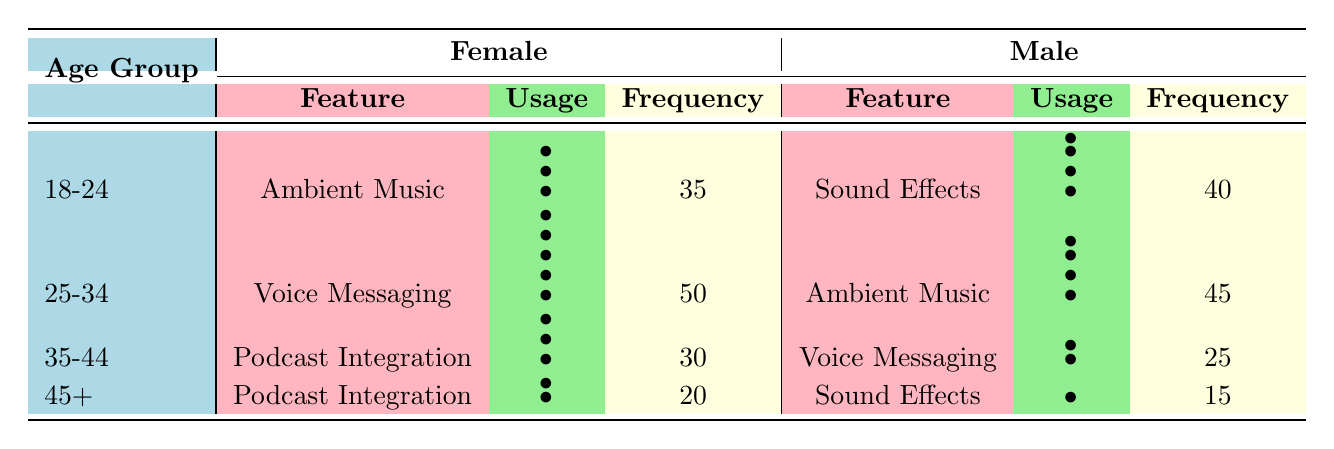What is the most frequently used sound feature by females aged 25-34? From the table, we can see that the frequency for "Voice Messaging" among females aged 25-34 is 50, which is the highest value listed in that row.
Answer: Voice Messaging How many sound features are listed for males in the age group 18-24? In the age group 18-24, the table lists one sound feature for males, which is "Sound Effects".
Answer: 1 What is the frequency of usage for Podcast Integration among females aged 35-44? The table shows that the frequency of usage for "Podcast Integration" among females aged 35-44 is 30.
Answer: 30 Which gender has a higher frequency of sound feature usage for Ambient Music in the 25-34 age group? The frequency for males is 45 while for females it is 0 in the table for that age group, therefore the males have a higher frequency.
Answer: Male What is the total frequency of Ambient Music usage across all age groups? From the table, Ambient Music is used 35 times by females in the age group 18-24 and 45 times by males in the age group 25-34. Adding these gives 35 + 45 = 80.
Answer: 80 Is the frequency of Voice Messaging higher for females in the 25-34 age group than males in the 35-44 age group? The frequency of Voice Messaging for females in the 25-34 age group is 50, while for males in the 35-44 age group it is 25. Since 50 is greater than 25, the statement is true.
Answer: Yes How does the total frequency of usage for sound effects in the 45+ age group compare to the total usage of ambient music in the 18-24 age group? The frequency of sound effects for males in the 45+ age group is 15, and the ambient music frequency for females in the 18-24 age group is 35. 15 is less than 35, so ambient music has a higher total.
Answer: Ambient music is higher What is the frequency difference for Podcast Integration between females aged 35-44 and females aged 45+? The frequency for females aged 35-44 is 30, while for females aged 45+ it is 20. The difference is 30 - 20 = 10.
Answer: 10 What sound feature do males in the age group 45+ use the least frequently? The table shows that males in the age group 45+ use "Sound Effects" with a frequency of 15, which is the only feature listed for that group, hence it is the least frequent.
Answer: Sound Effects 